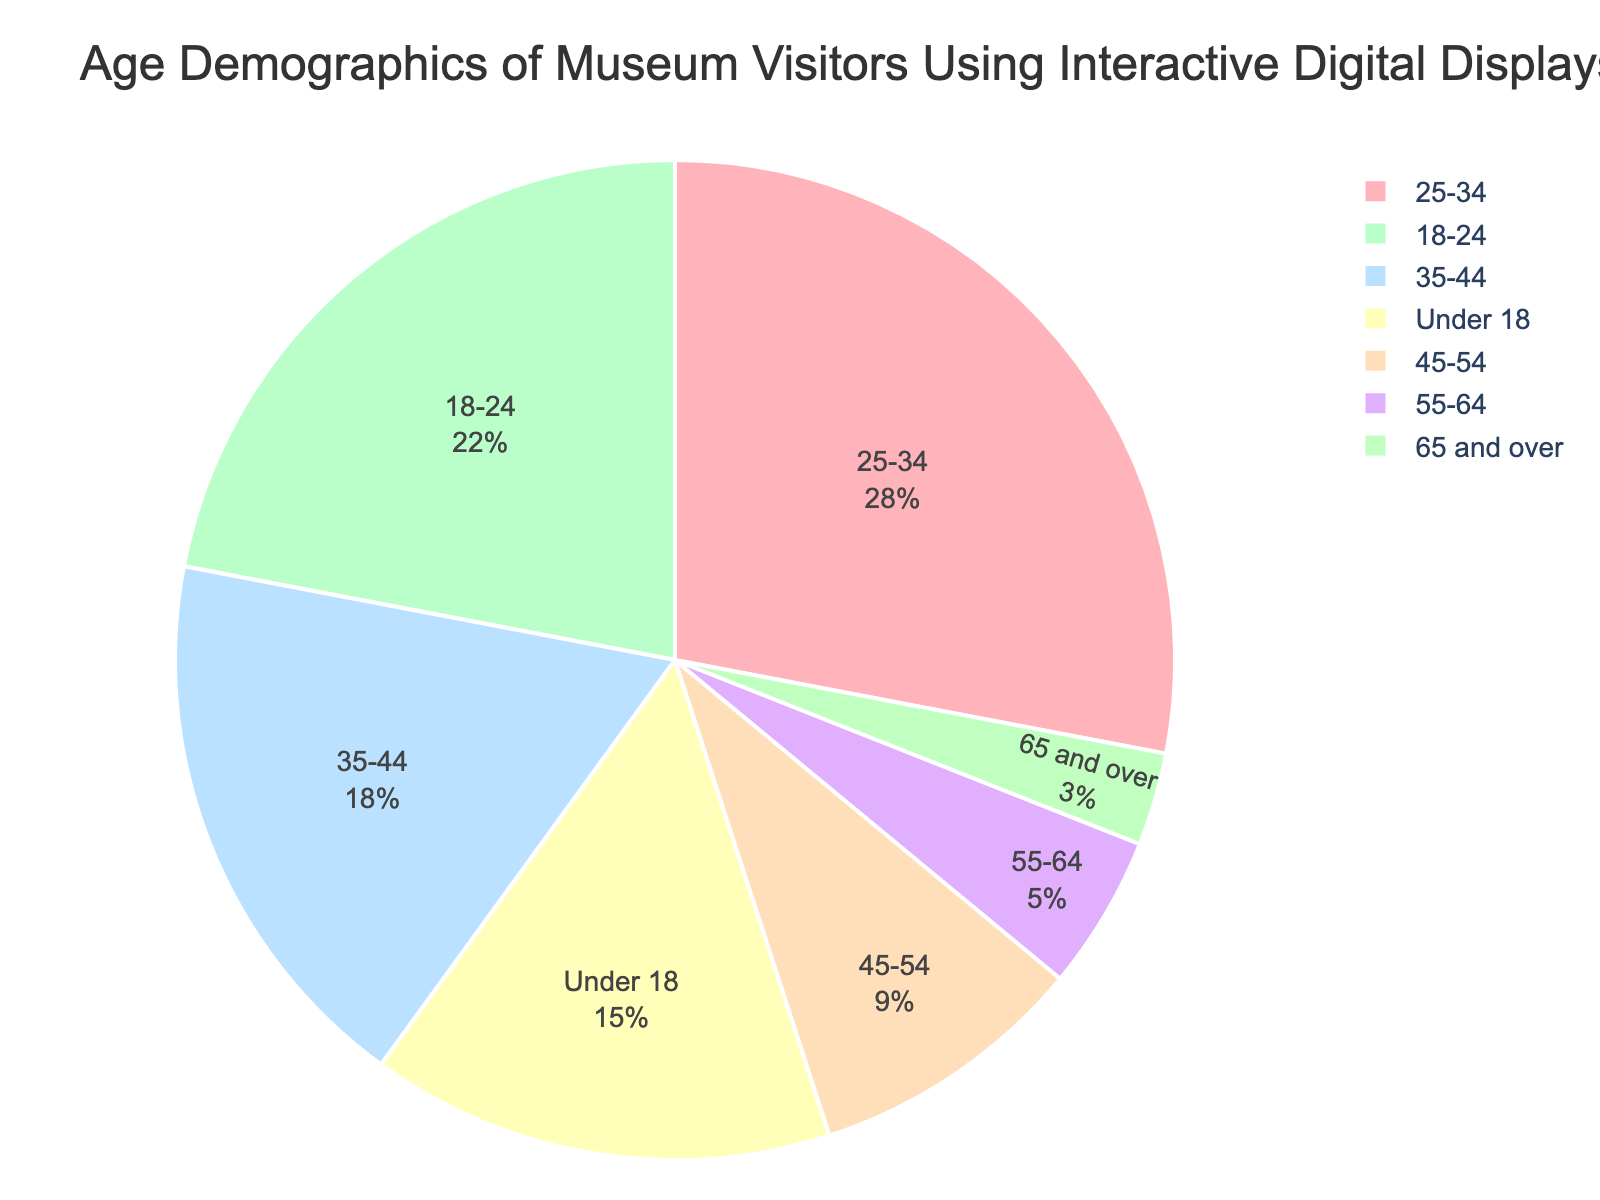What percentage of visitors are aged 25-34? Locate the segment labeled '25-34' on the pie chart. The percentage is displayed on the segment.
Answer: 28% Which age group constitutes the smallest percentage of visitors? Observe all the segments and identify the smallest one by size or labeled percentage.
Answer: 65 and over How much more is the percentage of 18-24-year-olds compared to 55-64-year-olds? Find the percentages for both age groups: 18-24 is 22% and 55-64 is 5%. Subtract the smaller percentage from the larger one: 22% - 5% = 17%.
Answer: 17% What is the combined percentage of visitors under 18 and 18-24? Find the percentages for both age groups: Under 18 is 15% and 18-24 is 22%. Add them together: 15% + 22% = 37%.
Answer: 37% Are there more visitors aged 35-44 or 45-54? By how much? Find the percentages for both age groups: 35-44 is 18% and 45-54 is 9%. Subtract the smaller percentage from the larger one: 18% - 9% = 9%.
Answer: 35-44 by 9% Which segment is depicted in green, and what percentage does it represent? Locate the green-colored segment in the pie chart, which is labeled '18-24' with a percentage.
Answer: 18-24, 22% What is the total percentage of visitors aged 45 and above? Sum the percentages of the age groups 45-54, 55-64, and 65 and over: 9% + 5% + 3% = 17%.
Answer: 17% Is the percentage of visitors aged 25-34 greater than the combined percentage of visitors aged 55-64 and 65 and over? Compare the percentage for the group aged 25-34 (28%) with the sum of the percentages for the groups aged 55-64 (5%) and 65 and over (3%): 5% + 3% = 8%, and 28% > 8%.
Answer: Yes What are the two age groups with combined percentages of less than 10%? Inspect the pie chart for age groups with percentages under 10%: 55-64 is 5%, and 65 and over is 3%. Their combined percentages are 5% + 3% = 8%.
Answer: 55-64 and 65 and over Which color represents the 'Under 18' age group, and what percentage does it account for? Identify the segment labeled 'Under 18' and note its color, which is pink in the chart, and the percentage labeled on it.
Answer: Pink, 15% 